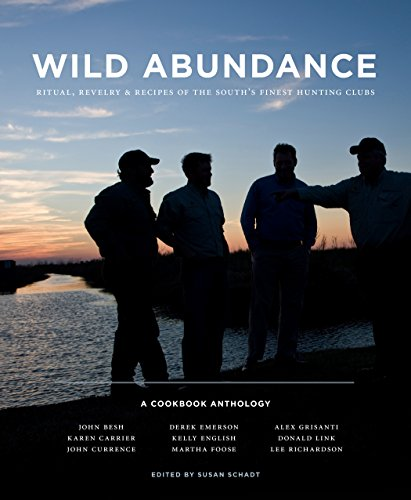Is this a historical book? No, this book primarily focuses on recipes and current culinary practices rather than delving deep into historical analysis. Any historical mentions are contextual, supporting the traditions of culinary practices rather than being the main focus. 